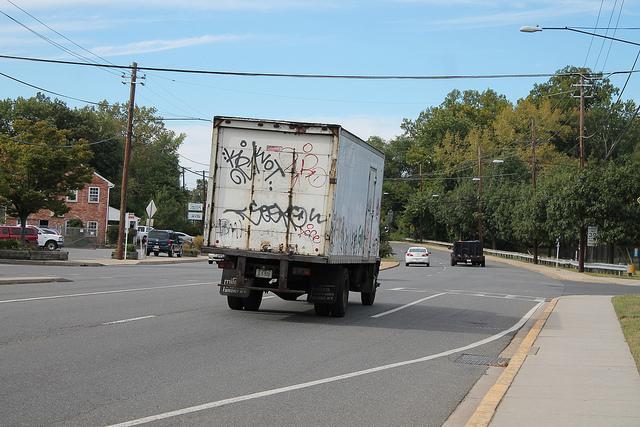How many skateboards are shown?
Give a very brief answer. 0. 